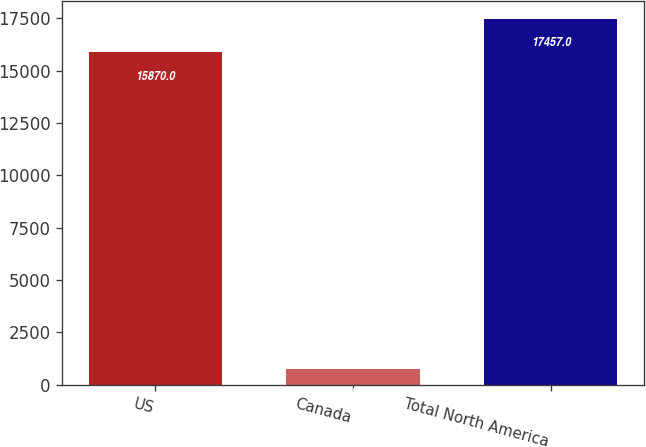Convert chart to OTSL. <chart><loc_0><loc_0><loc_500><loc_500><bar_chart><fcel>US<fcel>Canada<fcel>Total North America<nl><fcel>15870<fcel>748<fcel>17457<nl></chart> 